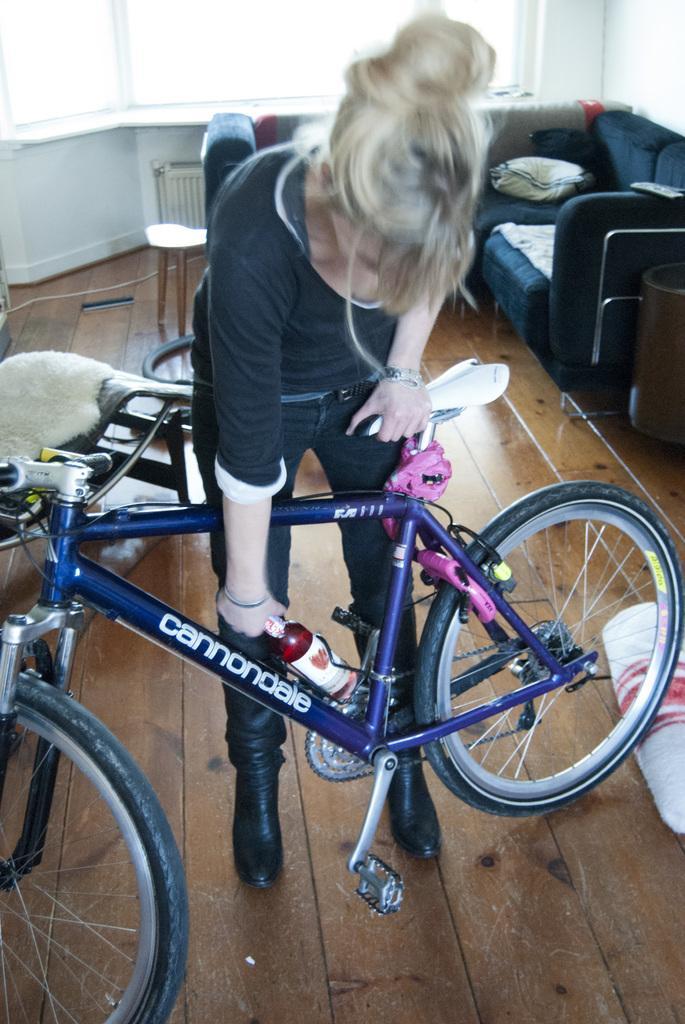Please provide a concise description of this image. This image consists of a woman holding a bottle and a bicycle. At the bottom, there is floor made up of wood. In the background, there is a sofa along with chair. And there is a wall along with window. 